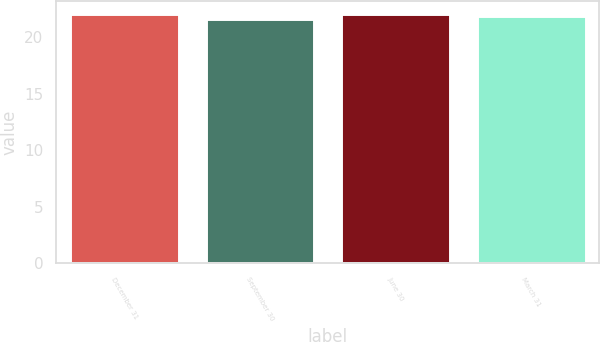<chart> <loc_0><loc_0><loc_500><loc_500><bar_chart><fcel>December 31<fcel>September 30<fcel>June 30<fcel>March 31<nl><fcel>22<fcel>21.6<fcel>22.04<fcel>21.85<nl></chart> 